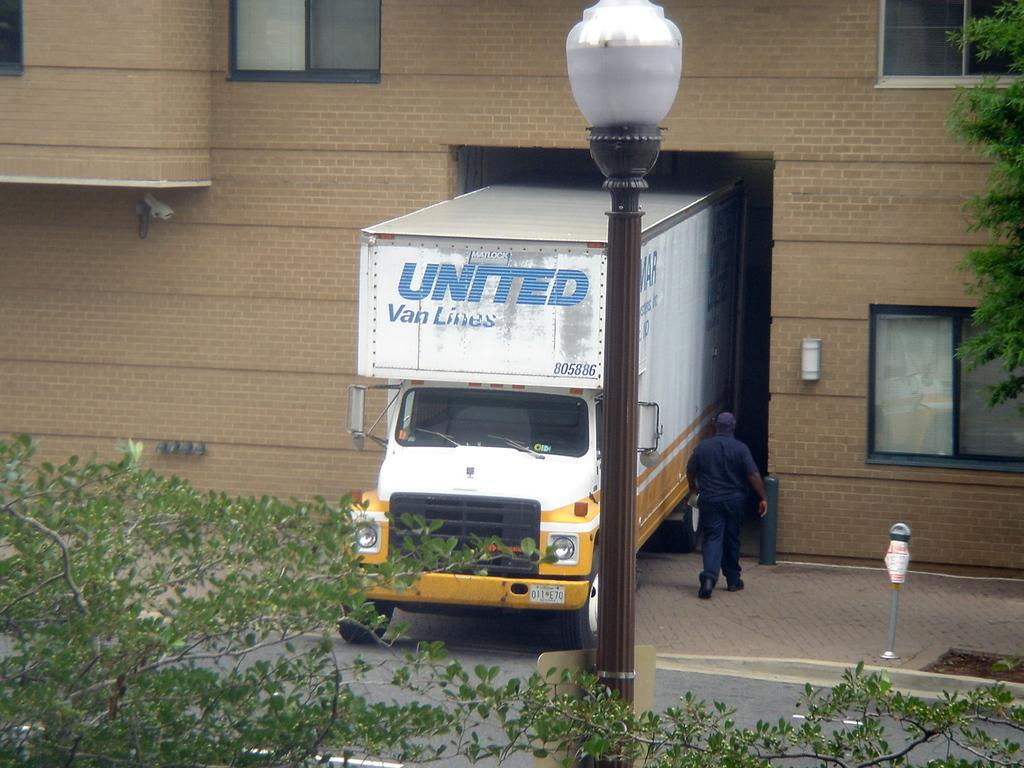What type of structure is present in the image? There is a building with windows in the image. What can be seen near the building? There is a truck and a person near the building. What is the purpose of the light pole in the image? The light pole provides illumination in the area. What type of vegetation is visible in the image? Branches of trees are visible in the image. What type of wall is visible in the image? There is no wall visible in the image; only a building, truck, person, light pole, and branches of trees are present. 